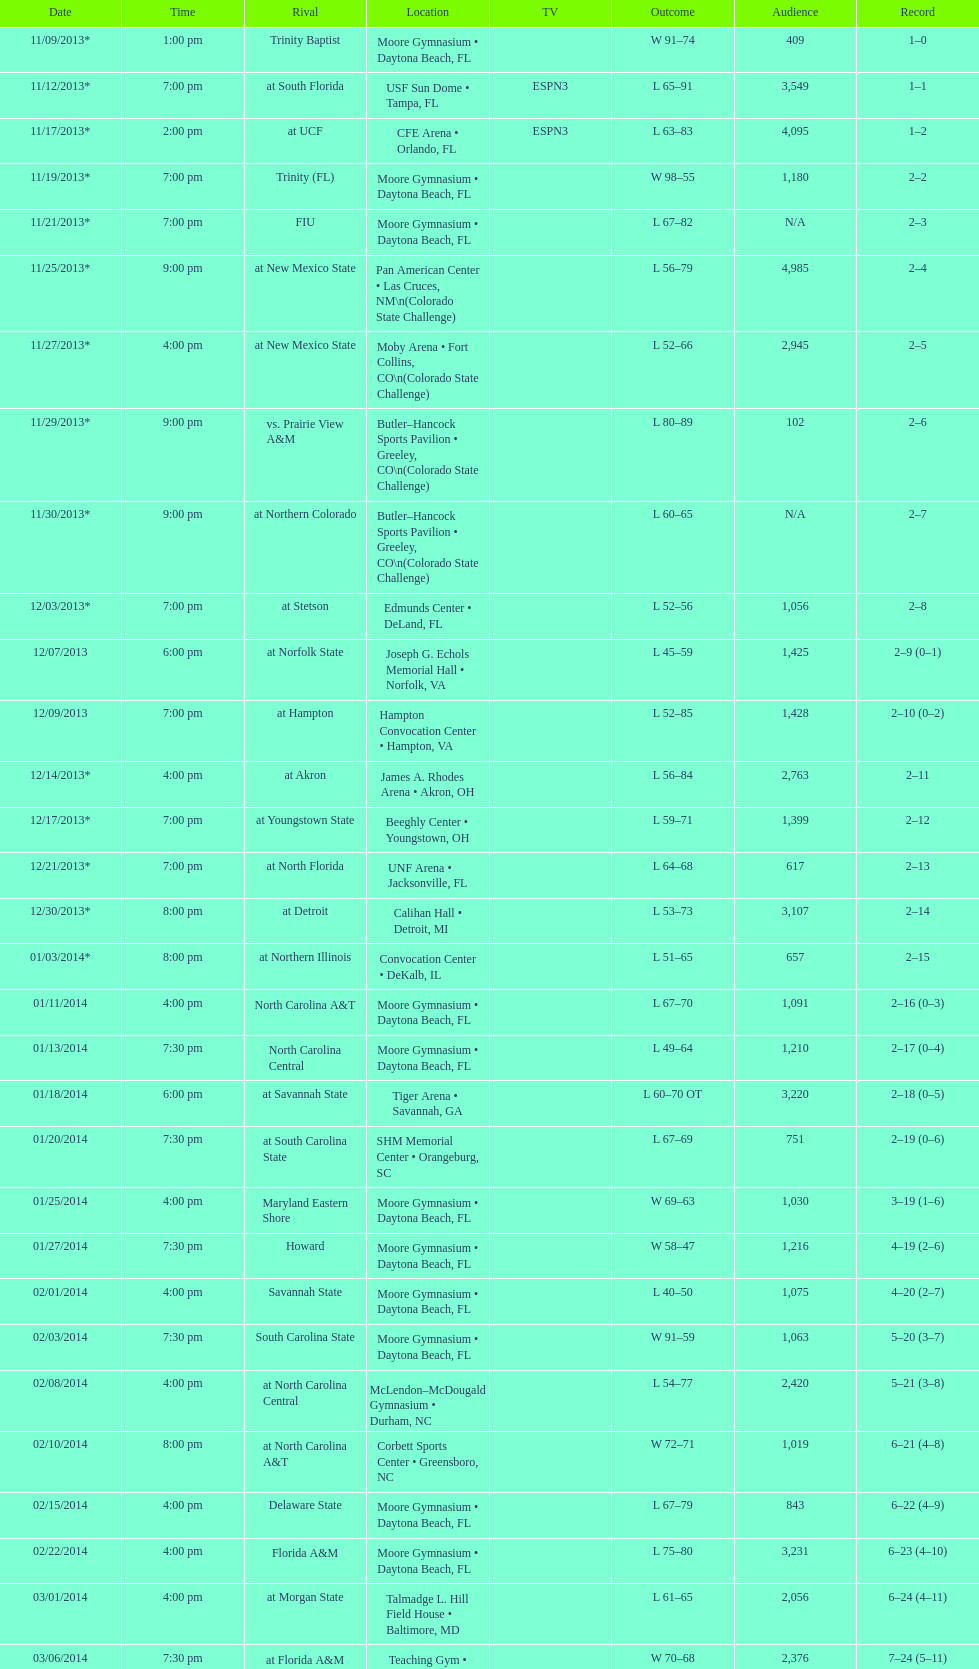How many teams had at most an attendance of 1,000? 6. 